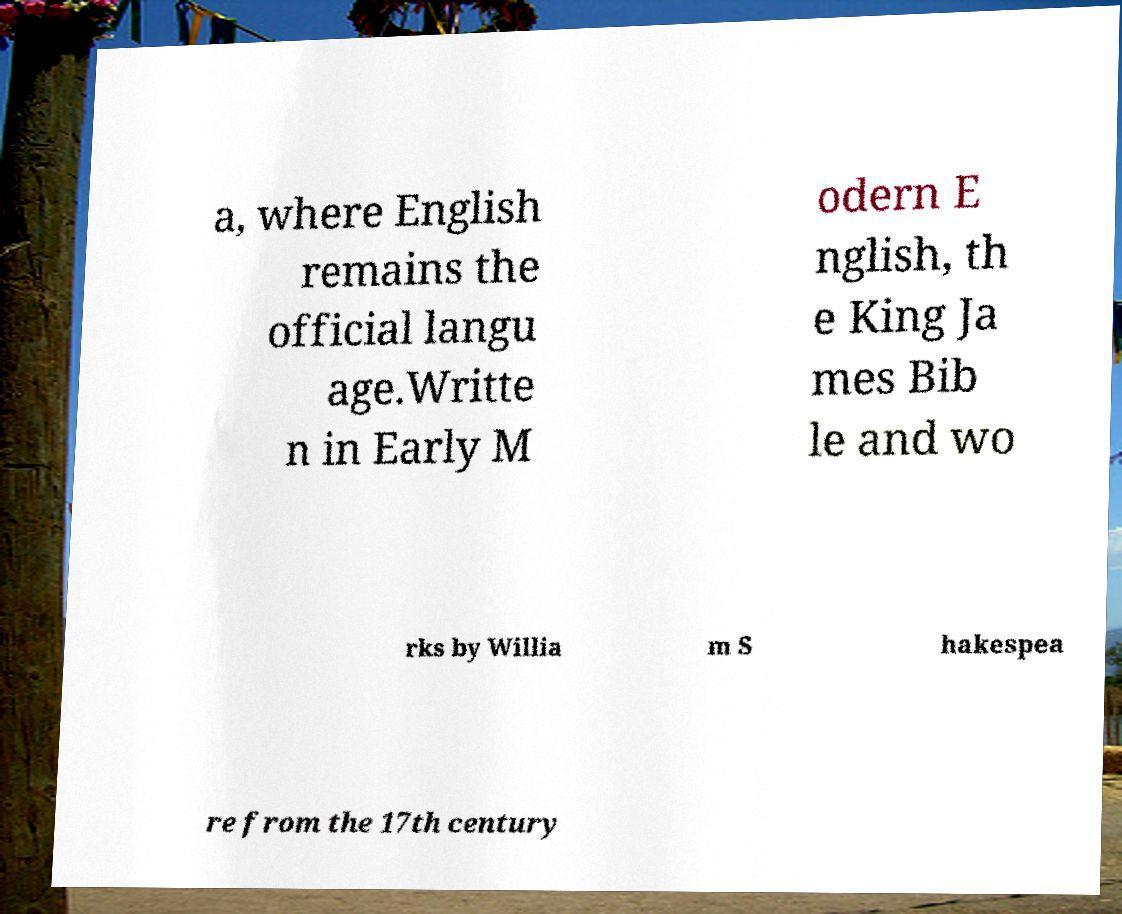I need the written content from this picture converted into text. Can you do that? a, where English remains the official langu age.Writte n in Early M odern E nglish, th e King Ja mes Bib le and wo rks by Willia m S hakespea re from the 17th century 